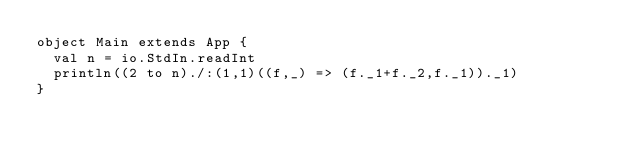<code> <loc_0><loc_0><loc_500><loc_500><_Scala_>object Main extends App {
  val n = io.StdIn.readInt
  println((2 to n)./:(1,1)((f,_) => (f._1+f._2,f._1))._1)
}
</code> 